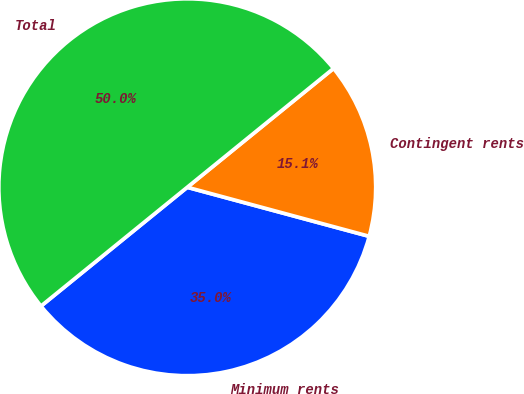<chart> <loc_0><loc_0><loc_500><loc_500><pie_chart><fcel>Minimum rents<fcel>Contingent rents<fcel>Total<nl><fcel>34.95%<fcel>15.05%<fcel>50.0%<nl></chart> 